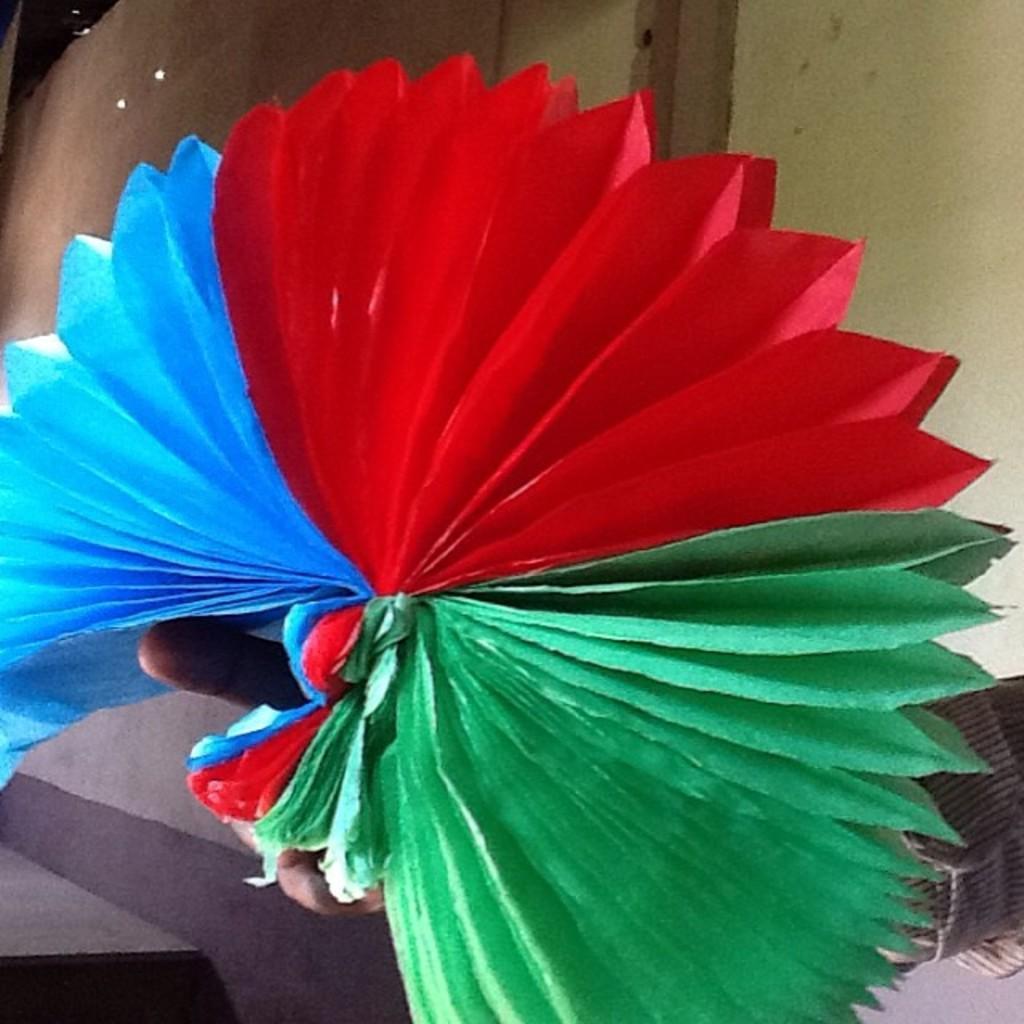In one or two sentences, can you explain what this image depicts? In this image we can see a person's hand holding an object which looks like a paper art. 